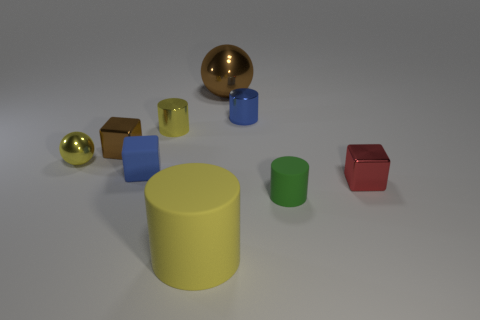The tiny metallic object that is the same color as the small rubber block is what shape?
Ensure brevity in your answer.  Cylinder. What is the size of the yellow thing to the left of the tiny metallic cube on the left side of the large brown metal thing?
Make the answer very short. Small. There is a metallic object that is right of the small blue shiny cylinder; does it have the same shape as the tiny matte object left of the brown shiny ball?
Your answer should be compact. Yes. Are there the same number of brown balls that are behind the large sphere and blocks?
Offer a terse response. No. There is another shiny thing that is the same shape as the blue shiny thing; what is its color?
Your response must be concise. Yellow. Does the thing that is behind the blue metallic thing have the same material as the small blue cylinder?
Give a very brief answer. Yes. What number of small objects are either gray shiny balls or brown metal cubes?
Offer a terse response. 1. How big is the red metal object?
Give a very brief answer. Small. There is a yellow matte thing; does it have the same size as the metallic object behind the tiny blue metallic cylinder?
Provide a short and direct response. Yes. What number of yellow objects are big cylinders or tiny metallic spheres?
Your response must be concise. 2. 